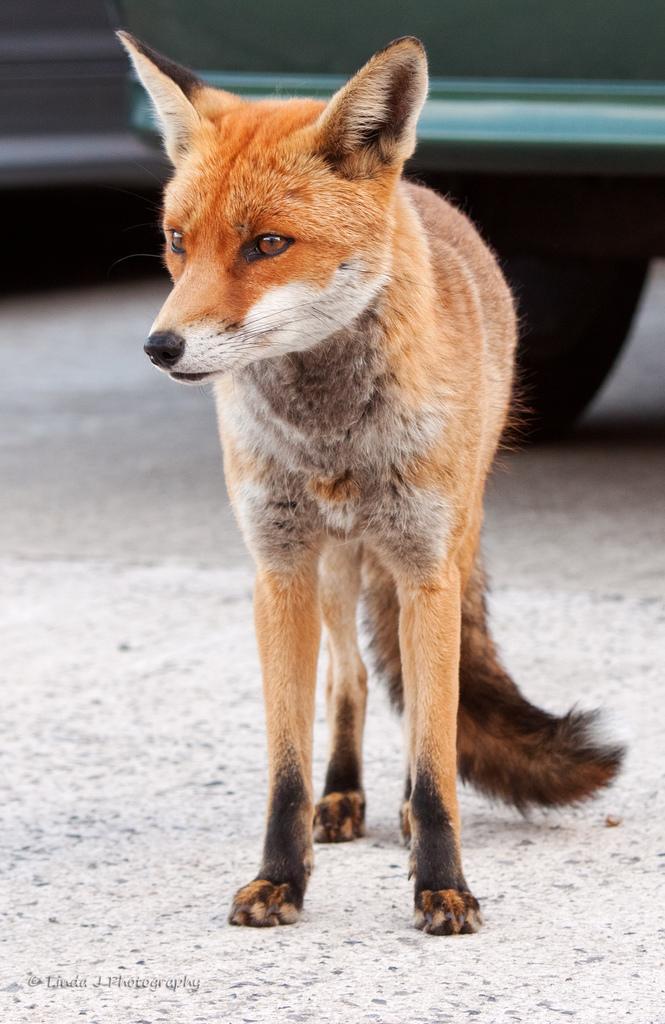Can you describe this image briefly? In the image we can see a red fox, road and vehicle. 